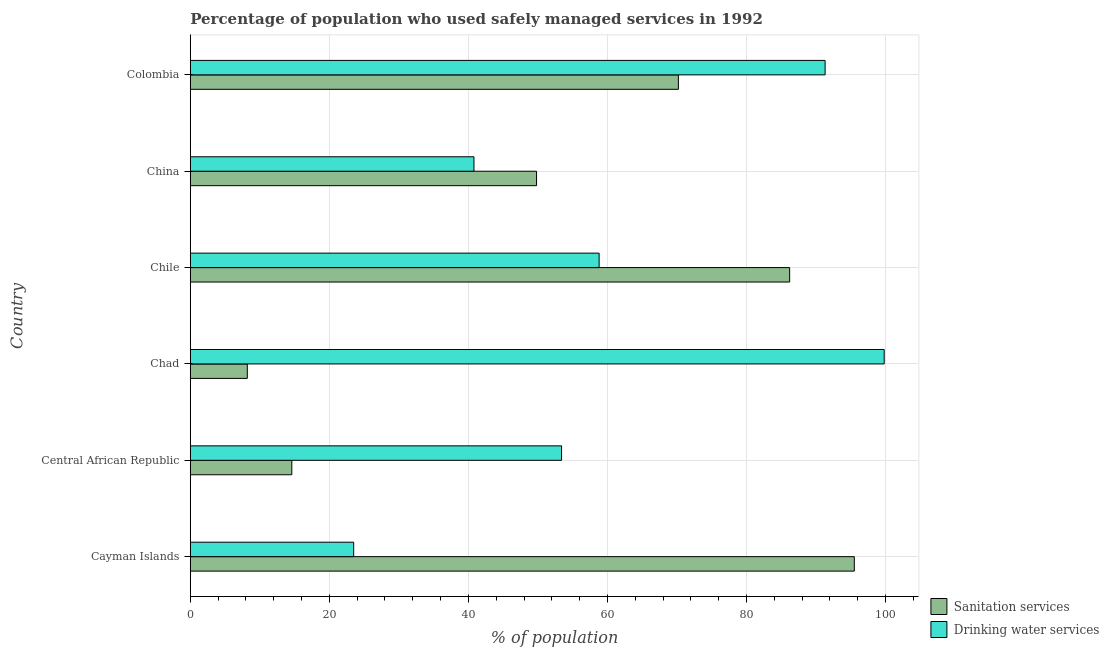How many different coloured bars are there?
Your answer should be very brief. 2. How many groups of bars are there?
Your answer should be very brief. 6. How many bars are there on the 5th tick from the bottom?
Ensure brevity in your answer.  2. What is the label of the 4th group of bars from the top?
Make the answer very short. Chad. In how many cases, is the number of bars for a given country not equal to the number of legend labels?
Provide a succinct answer. 0. Across all countries, what is the maximum percentage of population who used drinking water services?
Provide a short and direct response. 99.8. Across all countries, what is the minimum percentage of population who used drinking water services?
Offer a very short reply. 23.5. In which country was the percentage of population who used sanitation services maximum?
Offer a terse response. Cayman Islands. In which country was the percentage of population who used sanitation services minimum?
Provide a succinct answer. Chad. What is the total percentage of population who used sanitation services in the graph?
Provide a succinct answer. 324.5. What is the difference between the percentage of population who used drinking water services in Cayman Islands and that in Chad?
Ensure brevity in your answer.  -76.3. What is the difference between the percentage of population who used drinking water services in Colombia and the percentage of population who used sanitation services in Chile?
Your response must be concise. 5.1. What is the average percentage of population who used sanitation services per country?
Offer a very short reply. 54.08. What is the difference between the percentage of population who used drinking water services and percentage of population who used sanitation services in Colombia?
Give a very brief answer. 21.1. What is the ratio of the percentage of population who used drinking water services in Cayman Islands to that in Chile?
Keep it short and to the point. 0.4. Is the percentage of population who used sanitation services in Central African Republic less than that in Colombia?
Offer a very short reply. Yes. What is the difference between the highest and the second highest percentage of population who used drinking water services?
Provide a short and direct response. 8.5. What is the difference between the highest and the lowest percentage of population who used drinking water services?
Provide a succinct answer. 76.3. What does the 1st bar from the top in China represents?
Offer a terse response. Drinking water services. What does the 2nd bar from the bottom in Central African Republic represents?
Your response must be concise. Drinking water services. How many bars are there?
Ensure brevity in your answer.  12. What is the difference between two consecutive major ticks on the X-axis?
Provide a succinct answer. 20. Are the values on the major ticks of X-axis written in scientific E-notation?
Ensure brevity in your answer.  No. Does the graph contain grids?
Give a very brief answer. Yes. Where does the legend appear in the graph?
Keep it short and to the point. Bottom right. How many legend labels are there?
Give a very brief answer. 2. What is the title of the graph?
Ensure brevity in your answer.  Percentage of population who used safely managed services in 1992. Does "Female labor force" appear as one of the legend labels in the graph?
Your answer should be very brief. No. What is the label or title of the X-axis?
Give a very brief answer. % of population. What is the label or title of the Y-axis?
Keep it short and to the point. Country. What is the % of population in Sanitation services in Cayman Islands?
Provide a short and direct response. 95.5. What is the % of population in Drinking water services in Central African Republic?
Make the answer very short. 53.4. What is the % of population in Sanitation services in Chad?
Give a very brief answer. 8.2. What is the % of population of Drinking water services in Chad?
Offer a terse response. 99.8. What is the % of population of Sanitation services in Chile?
Make the answer very short. 86.2. What is the % of population in Drinking water services in Chile?
Your response must be concise. 58.8. What is the % of population of Sanitation services in China?
Your answer should be very brief. 49.8. What is the % of population of Drinking water services in China?
Ensure brevity in your answer.  40.8. What is the % of population in Sanitation services in Colombia?
Your answer should be compact. 70.2. What is the % of population in Drinking water services in Colombia?
Provide a short and direct response. 91.3. Across all countries, what is the maximum % of population of Sanitation services?
Offer a very short reply. 95.5. Across all countries, what is the maximum % of population of Drinking water services?
Ensure brevity in your answer.  99.8. Across all countries, what is the minimum % of population of Drinking water services?
Make the answer very short. 23.5. What is the total % of population in Sanitation services in the graph?
Make the answer very short. 324.5. What is the total % of population of Drinking water services in the graph?
Give a very brief answer. 367.6. What is the difference between the % of population of Sanitation services in Cayman Islands and that in Central African Republic?
Provide a succinct answer. 80.9. What is the difference between the % of population in Drinking water services in Cayman Islands and that in Central African Republic?
Your answer should be very brief. -29.9. What is the difference between the % of population in Sanitation services in Cayman Islands and that in Chad?
Your answer should be compact. 87.3. What is the difference between the % of population in Drinking water services in Cayman Islands and that in Chad?
Provide a short and direct response. -76.3. What is the difference between the % of population in Drinking water services in Cayman Islands and that in Chile?
Give a very brief answer. -35.3. What is the difference between the % of population in Sanitation services in Cayman Islands and that in China?
Make the answer very short. 45.7. What is the difference between the % of population of Drinking water services in Cayman Islands and that in China?
Your answer should be very brief. -17.3. What is the difference between the % of population of Sanitation services in Cayman Islands and that in Colombia?
Your answer should be compact. 25.3. What is the difference between the % of population in Drinking water services in Cayman Islands and that in Colombia?
Keep it short and to the point. -67.8. What is the difference between the % of population of Sanitation services in Central African Republic and that in Chad?
Provide a succinct answer. 6.4. What is the difference between the % of population in Drinking water services in Central African Republic and that in Chad?
Keep it short and to the point. -46.4. What is the difference between the % of population of Sanitation services in Central African Republic and that in Chile?
Offer a terse response. -71.6. What is the difference between the % of population in Drinking water services in Central African Republic and that in Chile?
Your response must be concise. -5.4. What is the difference between the % of population in Sanitation services in Central African Republic and that in China?
Your answer should be compact. -35.2. What is the difference between the % of population of Sanitation services in Central African Republic and that in Colombia?
Give a very brief answer. -55.6. What is the difference between the % of population in Drinking water services in Central African Republic and that in Colombia?
Give a very brief answer. -37.9. What is the difference between the % of population in Sanitation services in Chad and that in Chile?
Provide a succinct answer. -78. What is the difference between the % of population of Sanitation services in Chad and that in China?
Keep it short and to the point. -41.6. What is the difference between the % of population of Sanitation services in Chad and that in Colombia?
Offer a very short reply. -62. What is the difference between the % of population in Drinking water services in Chad and that in Colombia?
Provide a succinct answer. 8.5. What is the difference between the % of population of Sanitation services in Chile and that in China?
Give a very brief answer. 36.4. What is the difference between the % of population in Drinking water services in Chile and that in China?
Ensure brevity in your answer.  18. What is the difference between the % of population of Drinking water services in Chile and that in Colombia?
Keep it short and to the point. -32.5. What is the difference between the % of population of Sanitation services in China and that in Colombia?
Give a very brief answer. -20.4. What is the difference between the % of population in Drinking water services in China and that in Colombia?
Your response must be concise. -50.5. What is the difference between the % of population in Sanitation services in Cayman Islands and the % of population in Drinking water services in Central African Republic?
Offer a very short reply. 42.1. What is the difference between the % of population of Sanitation services in Cayman Islands and the % of population of Drinking water services in Chile?
Make the answer very short. 36.7. What is the difference between the % of population of Sanitation services in Cayman Islands and the % of population of Drinking water services in China?
Offer a very short reply. 54.7. What is the difference between the % of population in Sanitation services in Cayman Islands and the % of population in Drinking water services in Colombia?
Make the answer very short. 4.2. What is the difference between the % of population in Sanitation services in Central African Republic and the % of population in Drinking water services in Chad?
Your answer should be very brief. -85.2. What is the difference between the % of population in Sanitation services in Central African Republic and the % of population in Drinking water services in Chile?
Ensure brevity in your answer.  -44.2. What is the difference between the % of population in Sanitation services in Central African Republic and the % of population in Drinking water services in China?
Offer a very short reply. -26.2. What is the difference between the % of population in Sanitation services in Central African Republic and the % of population in Drinking water services in Colombia?
Ensure brevity in your answer.  -76.7. What is the difference between the % of population in Sanitation services in Chad and the % of population in Drinking water services in Chile?
Your response must be concise. -50.6. What is the difference between the % of population in Sanitation services in Chad and the % of population in Drinking water services in China?
Your response must be concise. -32.6. What is the difference between the % of population of Sanitation services in Chad and the % of population of Drinking water services in Colombia?
Offer a terse response. -83.1. What is the difference between the % of population of Sanitation services in Chile and the % of population of Drinking water services in China?
Offer a very short reply. 45.4. What is the difference between the % of population in Sanitation services in Chile and the % of population in Drinking water services in Colombia?
Provide a succinct answer. -5.1. What is the difference between the % of population in Sanitation services in China and the % of population in Drinking water services in Colombia?
Provide a short and direct response. -41.5. What is the average % of population of Sanitation services per country?
Provide a short and direct response. 54.08. What is the average % of population of Drinking water services per country?
Provide a succinct answer. 61.27. What is the difference between the % of population of Sanitation services and % of population of Drinking water services in Cayman Islands?
Offer a terse response. 72. What is the difference between the % of population of Sanitation services and % of population of Drinking water services in Central African Republic?
Ensure brevity in your answer.  -38.8. What is the difference between the % of population of Sanitation services and % of population of Drinking water services in Chad?
Offer a very short reply. -91.6. What is the difference between the % of population in Sanitation services and % of population in Drinking water services in Chile?
Make the answer very short. 27.4. What is the difference between the % of population of Sanitation services and % of population of Drinking water services in Colombia?
Offer a terse response. -21.1. What is the ratio of the % of population of Sanitation services in Cayman Islands to that in Central African Republic?
Provide a succinct answer. 6.54. What is the ratio of the % of population of Drinking water services in Cayman Islands to that in Central African Republic?
Provide a succinct answer. 0.44. What is the ratio of the % of population of Sanitation services in Cayman Islands to that in Chad?
Your answer should be compact. 11.65. What is the ratio of the % of population in Drinking water services in Cayman Islands to that in Chad?
Provide a short and direct response. 0.24. What is the ratio of the % of population of Sanitation services in Cayman Islands to that in Chile?
Provide a short and direct response. 1.11. What is the ratio of the % of population of Drinking water services in Cayman Islands to that in Chile?
Provide a succinct answer. 0.4. What is the ratio of the % of population of Sanitation services in Cayman Islands to that in China?
Make the answer very short. 1.92. What is the ratio of the % of population of Drinking water services in Cayman Islands to that in China?
Ensure brevity in your answer.  0.58. What is the ratio of the % of population of Sanitation services in Cayman Islands to that in Colombia?
Provide a succinct answer. 1.36. What is the ratio of the % of population of Drinking water services in Cayman Islands to that in Colombia?
Offer a terse response. 0.26. What is the ratio of the % of population of Sanitation services in Central African Republic to that in Chad?
Make the answer very short. 1.78. What is the ratio of the % of population in Drinking water services in Central African Republic to that in Chad?
Provide a short and direct response. 0.54. What is the ratio of the % of population of Sanitation services in Central African Republic to that in Chile?
Ensure brevity in your answer.  0.17. What is the ratio of the % of population in Drinking water services in Central African Republic to that in Chile?
Offer a very short reply. 0.91. What is the ratio of the % of population in Sanitation services in Central African Republic to that in China?
Provide a succinct answer. 0.29. What is the ratio of the % of population of Drinking water services in Central African Republic to that in China?
Your answer should be compact. 1.31. What is the ratio of the % of population in Sanitation services in Central African Republic to that in Colombia?
Your response must be concise. 0.21. What is the ratio of the % of population in Drinking water services in Central African Republic to that in Colombia?
Offer a terse response. 0.58. What is the ratio of the % of population of Sanitation services in Chad to that in Chile?
Your answer should be very brief. 0.1. What is the ratio of the % of population of Drinking water services in Chad to that in Chile?
Your response must be concise. 1.7. What is the ratio of the % of population in Sanitation services in Chad to that in China?
Offer a terse response. 0.16. What is the ratio of the % of population in Drinking water services in Chad to that in China?
Provide a short and direct response. 2.45. What is the ratio of the % of population in Sanitation services in Chad to that in Colombia?
Provide a succinct answer. 0.12. What is the ratio of the % of population of Drinking water services in Chad to that in Colombia?
Offer a terse response. 1.09. What is the ratio of the % of population in Sanitation services in Chile to that in China?
Provide a short and direct response. 1.73. What is the ratio of the % of population in Drinking water services in Chile to that in China?
Provide a succinct answer. 1.44. What is the ratio of the % of population of Sanitation services in Chile to that in Colombia?
Your answer should be compact. 1.23. What is the ratio of the % of population in Drinking water services in Chile to that in Colombia?
Give a very brief answer. 0.64. What is the ratio of the % of population in Sanitation services in China to that in Colombia?
Keep it short and to the point. 0.71. What is the ratio of the % of population in Drinking water services in China to that in Colombia?
Provide a succinct answer. 0.45. What is the difference between the highest and the second highest % of population in Sanitation services?
Give a very brief answer. 9.3. What is the difference between the highest and the lowest % of population in Sanitation services?
Provide a short and direct response. 87.3. What is the difference between the highest and the lowest % of population of Drinking water services?
Keep it short and to the point. 76.3. 